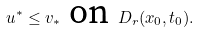<formula> <loc_0><loc_0><loc_500><loc_500>u ^ { * } \leq v _ { * } \text { on } D _ { r } ( x _ { 0 } , t _ { 0 } ) .</formula> 